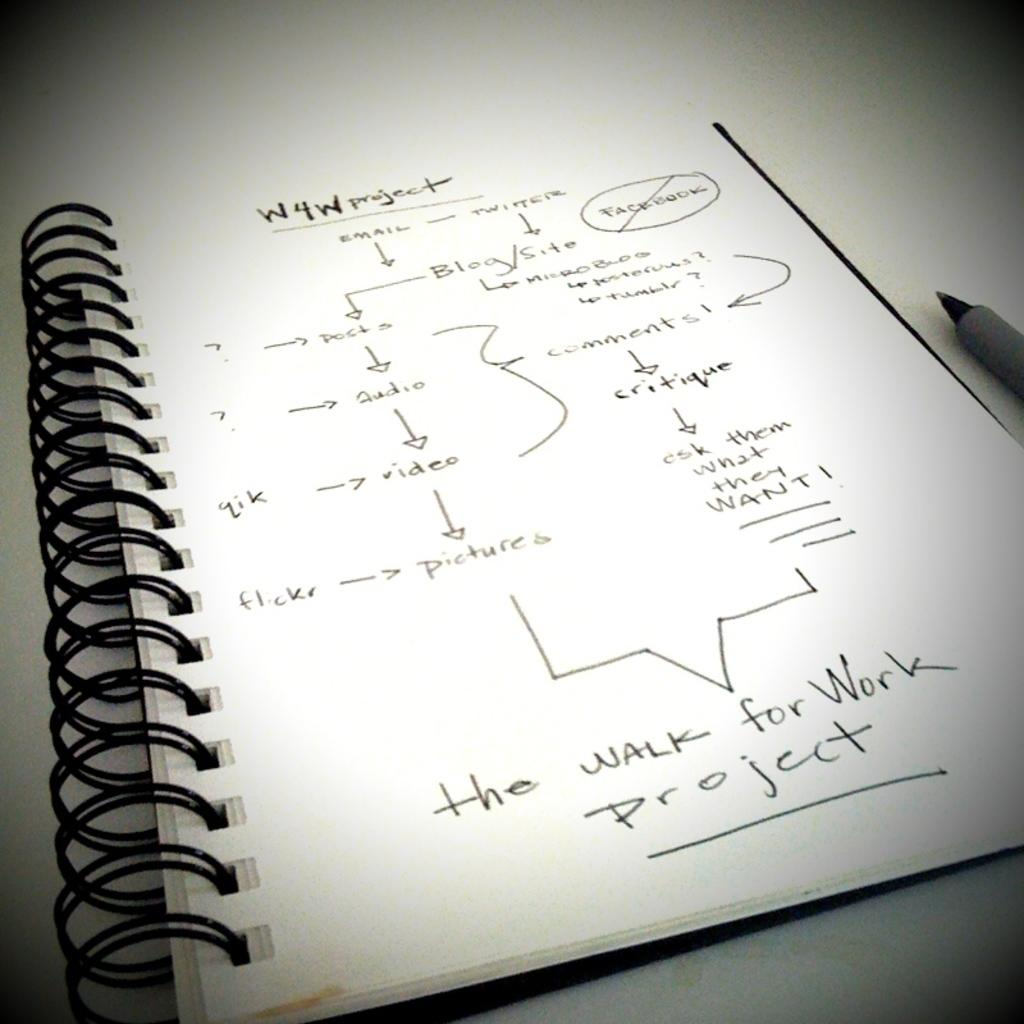<image>
Present a compact description of the photo's key features. A notebook that is opened to a page laying out information for the W4W Project has it ending with the Walk for Work Project. 